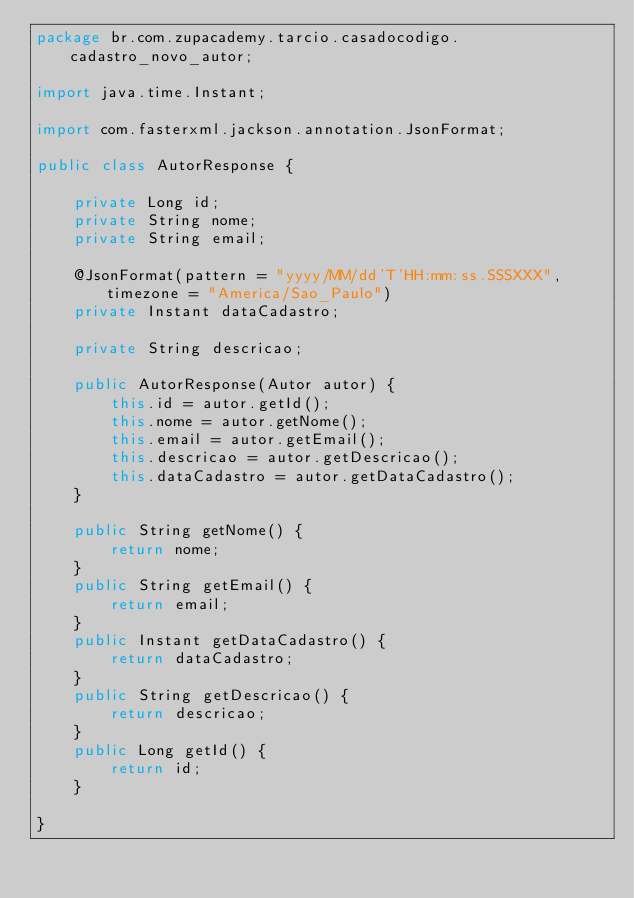<code> <loc_0><loc_0><loc_500><loc_500><_Java_>package br.com.zupacademy.tarcio.casadocodigo.cadastro_novo_autor;

import java.time.Instant;

import com.fasterxml.jackson.annotation.JsonFormat;

public class AutorResponse {
	
	private Long id;
	private String nome;
	private String email;
	
	@JsonFormat(pattern = "yyyy/MM/dd'T'HH:mm:ss.SSSXXX", timezone = "America/Sao_Paulo")
	private Instant dataCadastro;
	
	private String descricao;
	
	public AutorResponse(Autor autor) {
		this.id = autor.getId();
		this.nome = autor.getNome();
		this.email = autor.getEmail();
		this.descricao = autor.getDescricao();
		this.dataCadastro = autor.getDataCadastro();
	}
	
	public String getNome() {
		return nome;
	}
	public String getEmail() {
		return email;
	}
	public Instant getDataCadastro() {
		return dataCadastro;
	}
	public String getDescricao() {
		return descricao;
	}
	public Long getId() {
		return id;
	}
	
}
</code> 